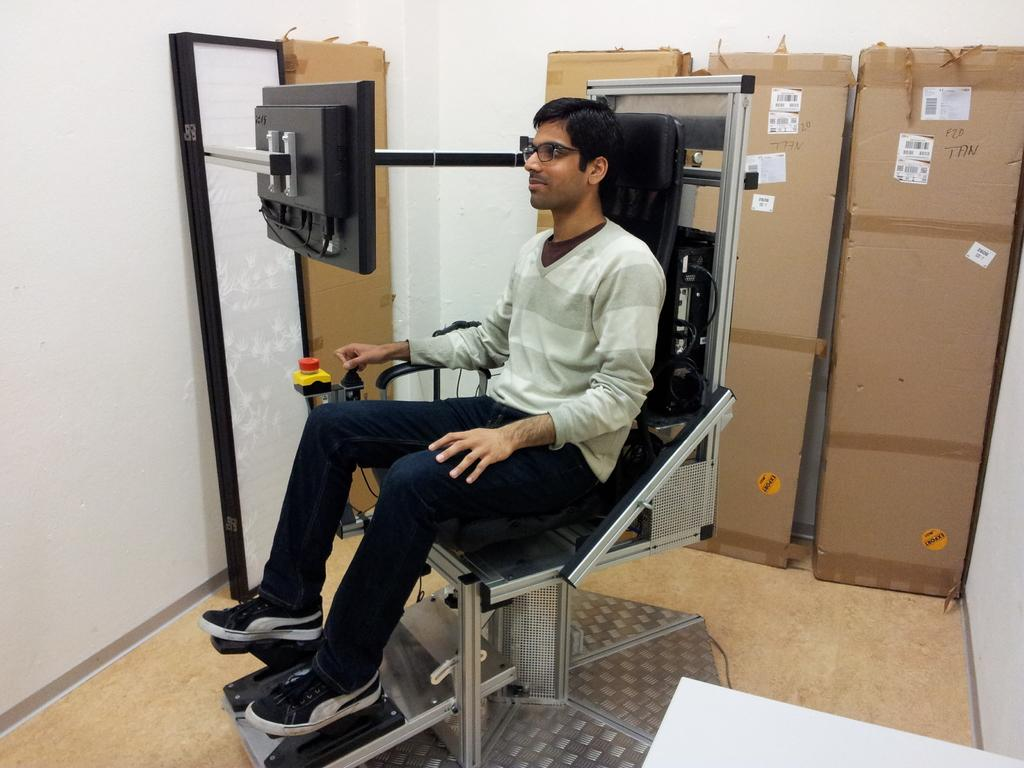What is the person in the image doing? The person is sitting on a chair in the image. What is in front of the person? There is a screen in front of the person. What other objects can be seen in the image? There are boxes in the image. Can you describe the board near the wall in the image? There is a board near the wall in the image. How many girls are visible in the image? There are no girls visible in the image; it only features a person sitting on a chair. What type of cracker is being used to prop open the door in the image? There is no cracker or door present in the image. 